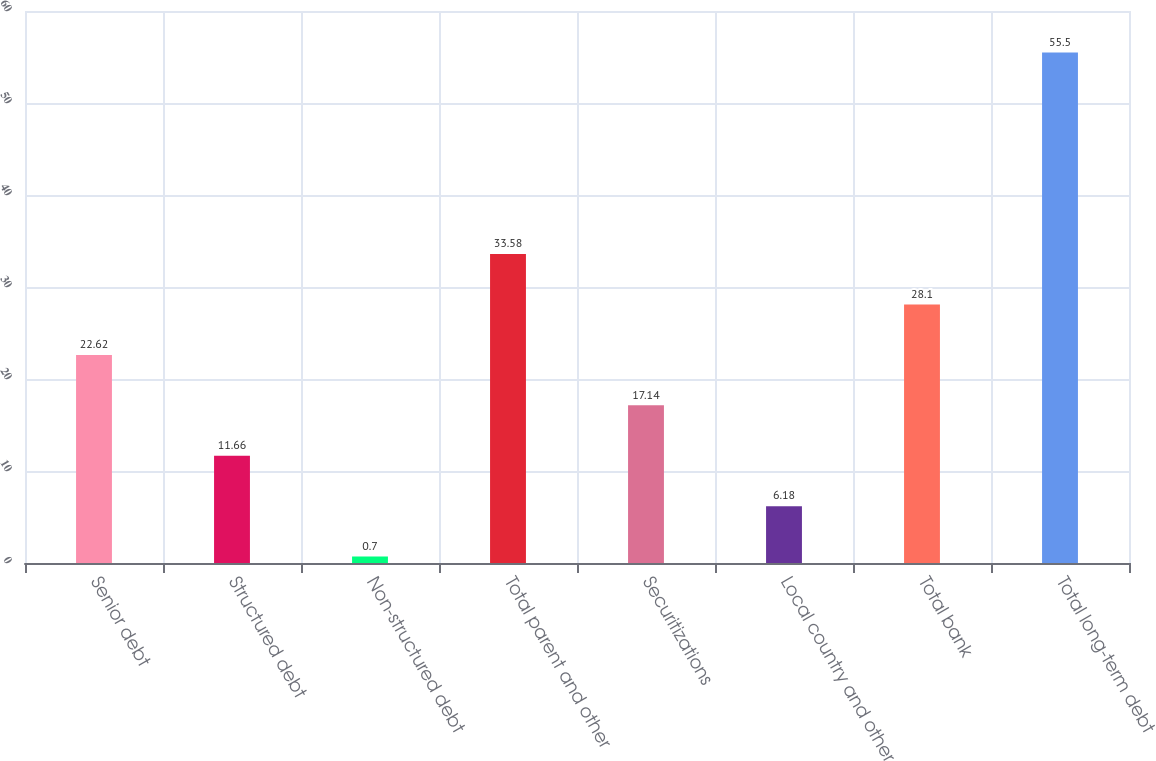Convert chart. <chart><loc_0><loc_0><loc_500><loc_500><bar_chart><fcel>Senior debt<fcel>Structured debt<fcel>Non-structured debt<fcel>Total parent and other<fcel>Securitizations<fcel>Local country and other<fcel>Total bank<fcel>Total long-term debt<nl><fcel>22.62<fcel>11.66<fcel>0.7<fcel>33.58<fcel>17.14<fcel>6.18<fcel>28.1<fcel>55.5<nl></chart> 